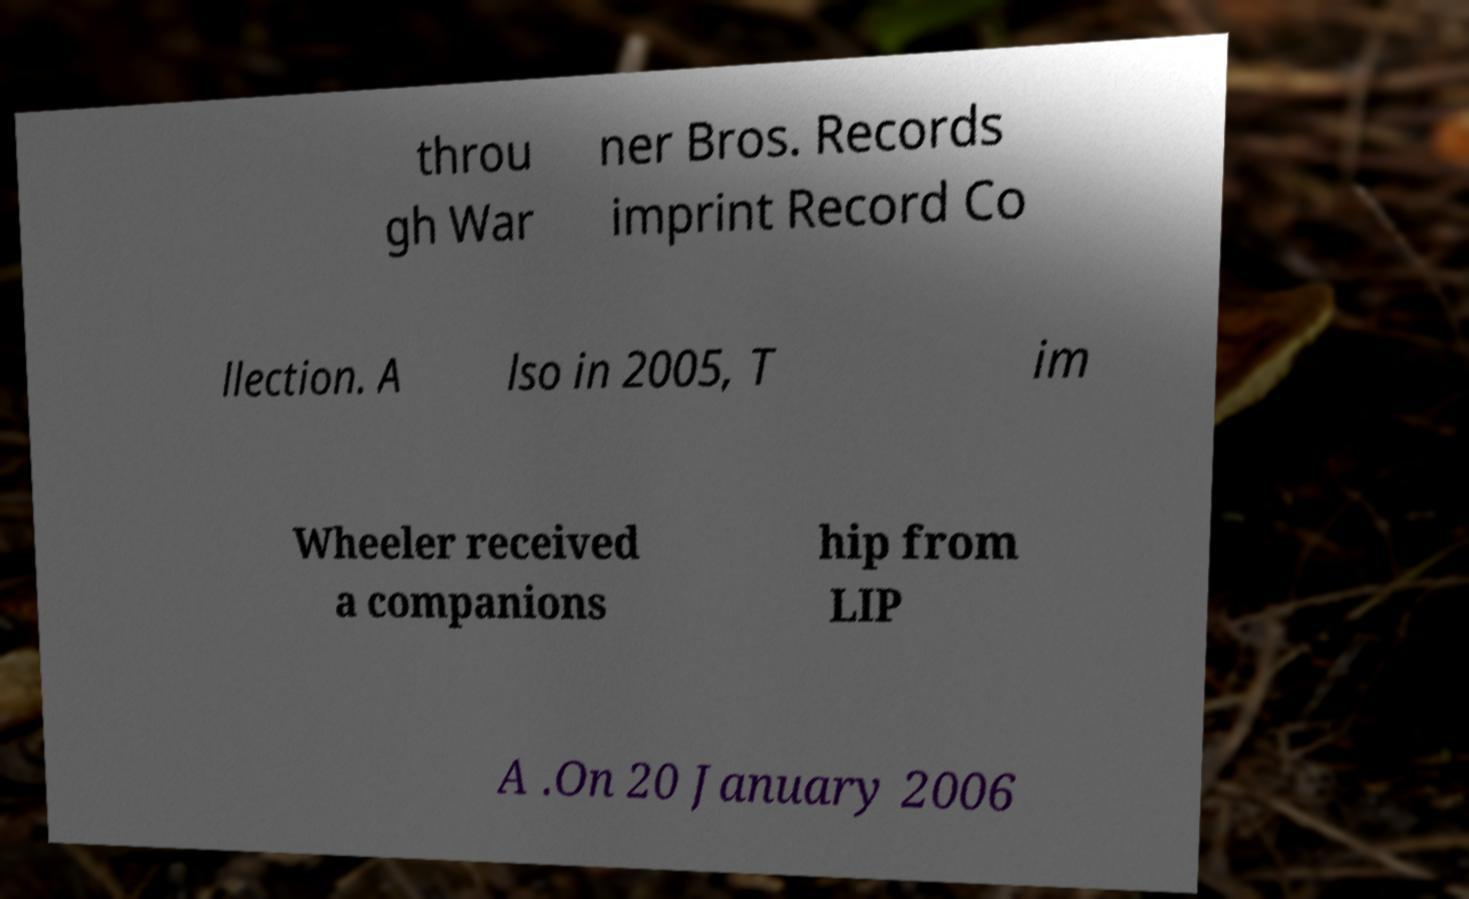Can you accurately transcribe the text from the provided image for me? throu gh War ner Bros. Records imprint Record Co llection. A lso in 2005, T im Wheeler received a companions hip from LIP A .On 20 January 2006 